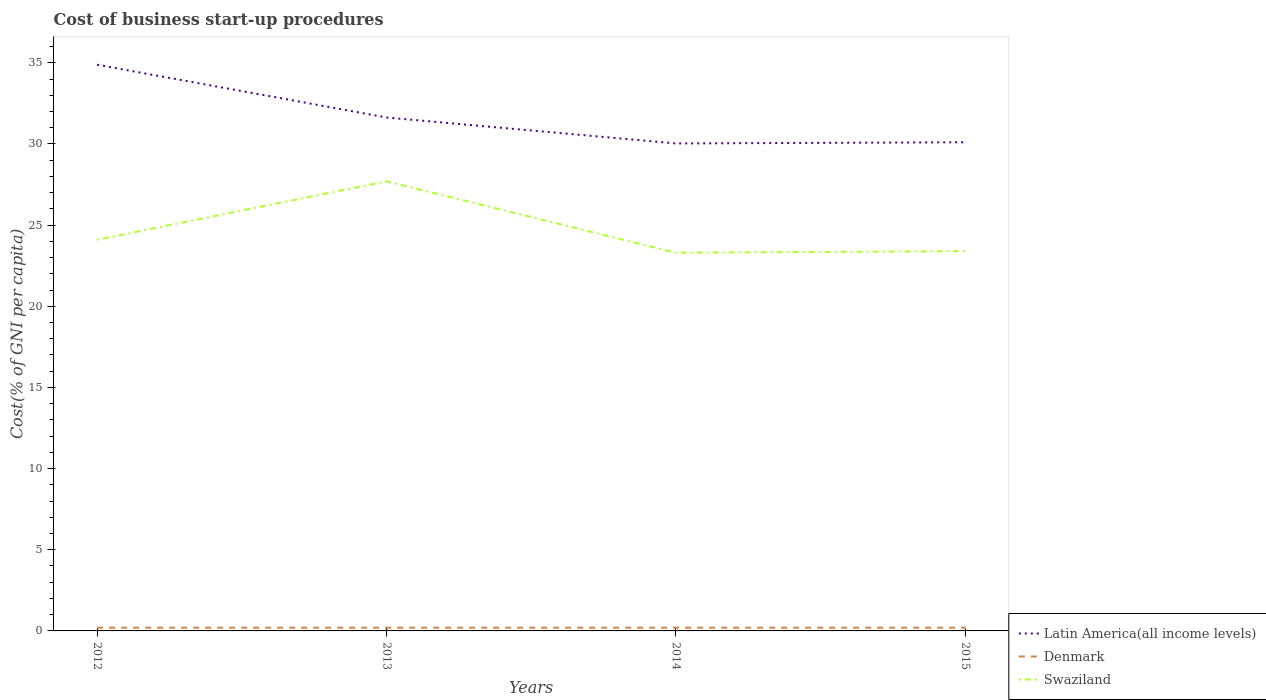Does the line corresponding to Swaziland intersect with the line corresponding to Latin America(all income levels)?
Give a very brief answer. No. Is the number of lines equal to the number of legend labels?
Keep it short and to the point. Yes. Across all years, what is the maximum cost of business start-up procedures in Swaziland?
Your answer should be compact. 23.3. What is the total cost of business start-up procedures in Latin America(all income levels) in the graph?
Keep it short and to the point. -0.07. What is the difference between the highest and the second highest cost of business start-up procedures in Latin America(all income levels)?
Keep it short and to the point. 4.85. What is the difference between the highest and the lowest cost of business start-up procedures in Latin America(all income levels)?
Provide a succinct answer. 1. Is the cost of business start-up procedures in Denmark strictly greater than the cost of business start-up procedures in Latin America(all income levels) over the years?
Your answer should be compact. Yes. How many lines are there?
Your answer should be very brief. 3. How many years are there in the graph?
Keep it short and to the point. 4. What is the difference between two consecutive major ticks on the Y-axis?
Provide a short and direct response. 5. Are the values on the major ticks of Y-axis written in scientific E-notation?
Offer a very short reply. No. How are the legend labels stacked?
Provide a short and direct response. Vertical. What is the title of the graph?
Your answer should be compact. Cost of business start-up procedures. Does "French Polynesia" appear as one of the legend labels in the graph?
Your response must be concise. No. What is the label or title of the X-axis?
Keep it short and to the point. Years. What is the label or title of the Y-axis?
Your response must be concise. Cost(% of GNI per capita). What is the Cost(% of GNI per capita) in Latin America(all income levels) in 2012?
Ensure brevity in your answer.  34.88. What is the Cost(% of GNI per capita) of Denmark in 2012?
Provide a succinct answer. 0.2. What is the Cost(% of GNI per capita) of Swaziland in 2012?
Offer a terse response. 24.1. What is the Cost(% of GNI per capita) in Latin America(all income levels) in 2013?
Give a very brief answer. 31.63. What is the Cost(% of GNI per capita) of Swaziland in 2013?
Keep it short and to the point. 27.7. What is the Cost(% of GNI per capita) of Latin America(all income levels) in 2014?
Make the answer very short. 30.03. What is the Cost(% of GNI per capita) in Swaziland in 2014?
Your answer should be compact. 23.3. What is the Cost(% of GNI per capita) of Latin America(all income levels) in 2015?
Make the answer very short. 30.11. What is the Cost(% of GNI per capita) in Denmark in 2015?
Give a very brief answer. 0.2. What is the Cost(% of GNI per capita) in Swaziland in 2015?
Provide a short and direct response. 23.4. Across all years, what is the maximum Cost(% of GNI per capita) in Latin America(all income levels)?
Keep it short and to the point. 34.88. Across all years, what is the maximum Cost(% of GNI per capita) of Swaziland?
Make the answer very short. 27.7. Across all years, what is the minimum Cost(% of GNI per capita) of Latin America(all income levels)?
Make the answer very short. 30.03. Across all years, what is the minimum Cost(% of GNI per capita) of Swaziland?
Keep it short and to the point. 23.3. What is the total Cost(% of GNI per capita) in Latin America(all income levels) in the graph?
Offer a very short reply. 126.66. What is the total Cost(% of GNI per capita) of Denmark in the graph?
Offer a terse response. 0.8. What is the total Cost(% of GNI per capita) of Swaziland in the graph?
Offer a terse response. 98.5. What is the difference between the Cost(% of GNI per capita) of Latin America(all income levels) in 2012 and that in 2013?
Your answer should be very brief. 3.25. What is the difference between the Cost(% of GNI per capita) of Denmark in 2012 and that in 2013?
Your answer should be compact. 0. What is the difference between the Cost(% of GNI per capita) of Latin America(all income levels) in 2012 and that in 2014?
Keep it short and to the point. 4.85. What is the difference between the Cost(% of GNI per capita) of Latin America(all income levels) in 2012 and that in 2015?
Keep it short and to the point. 4.78. What is the difference between the Cost(% of GNI per capita) of Denmark in 2012 and that in 2015?
Your response must be concise. 0. What is the difference between the Cost(% of GNI per capita) in Swaziland in 2012 and that in 2015?
Ensure brevity in your answer.  0.7. What is the difference between the Cost(% of GNI per capita) of Swaziland in 2013 and that in 2014?
Ensure brevity in your answer.  4.4. What is the difference between the Cost(% of GNI per capita) in Latin America(all income levels) in 2013 and that in 2015?
Provide a short and direct response. 1.53. What is the difference between the Cost(% of GNI per capita) in Denmark in 2013 and that in 2015?
Ensure brevity in your answer.  0. What is the difference between the Cost(% of GNI per capita) of Swaziland in 2013 and that in 2015?
Offer a very short reply. 4.3. What is the difference between the Cost(% of GNI per capita) of Latin America(all income levels) in 2014 and that in 2015?
Your answer should be compact. -0.07. What is the difference between the Cost(% of GNI per capita) of Denmark in 2014 and that in 2015?
Offer a very short reply. 0. What is the difference between the Cost(% of GNI per capita) of Swaziland in 2014 and that in 2015?
Offer a very short reply. -0.1. What is the difference between the Cost(% of GNI per capita) in Latin America(all income levels) in 2012 and the Cost(% of GNI per capita) in Denmark in 2013?
Your response must be concise. 34.68. What is the difference between the Cost(% of GNI per capita) in Latin America(all income levels) in 2012 and the Cost(% of GNI per capita) in Swaziland in 2013?
Provide a succinct answer. 7.18. What is the difference between the Cost(% of GNI per capita) in Denmark in 2012 and the Cost(% of GNI per capita) in Swaziland in 2013?
Your answer should be very brief. -27.5. What is the difference between the Cost(% of GNI per capita) in Latin America(all income levels) in 2012 and the Cost(% of GNI per capita) in Denmark in 2014?
Your answer should be compact. 34.68. What is the difference between the Cost(% of GNI per capita) in Latin America(all income levels) in 2012 and the Cost(% of GNI per capita) in Swaziland in 2014?
Offer a terse response. 11.58. What is the difference between the Cost(% of GNI per capita) of Denmark in 2012 and the Cost(% of GNI per capita) of Swaziland in 2014?
Your answer should be very brief. -23.1. What is the difference between the Cost(% of GNI per capita) in Latin America(all income levels) in 2012 and the Cost(% of GNI per capita) in Denmark in 2015?
Provide a short and direct response. 34.68. What is the difference between the Cost(% of GNI per capita) in Latin America(all income levels) in 2012 and the Cost(% of GNI per capita) in Swaziland in 2015?
Your answer should be compact. 11.48. What is the difference between the Cost(% of GNI per capita) of Denmark in 2012 and the Cost(% of GNI per capita) of Swaziland in 2015?
Offer a very short reply. -23.2. What is the difference between the Cost(% of GNI per capita) of Latin America(all income levels) in 2013 and the Cost(% of GNI per capita) of Denmark in 2014?
Your response must be concise. 31.43. What is the difference between the Cost(% of GNI per capita) in Latin America(all income levels) in 2013 and the Cost(% of GNI per capita) in Swaziland in 2014?
Provide a succinct answer. 8.33. What is the difference between the Cost(% of GNI per capita) of Denmark in 2013 and the Cost(% of GNI per capita) of Swaziland in 2014?
Offer a very short reply. -23.1. What is the difference between the Cost(% of GNI per capita) in Latin America(all income levels) in 2013 and the Cost(% of GNI per capita) in Denmark in 2015?
Your response must be concise. 31.43. What is the difference between the Cost(% of GNI per capita) of Latin America(all income levels) in 2013 and the Cost(% of GNI per capita) of Swaziland in 2015?
Your answer should be very brief. 8.23. What is the difference between the Cost(% of GNI per capita) of Denmark in 2013 and the Cost(% of GNI per capita) of Swaziland in 2015?
Offer a very short reply. -23.2. What is the difference between the Cost(% of GNI per capita) of Latin America(all income levels) in 2014 and the Cost(% of GNI per capita) of Denmark in 2015?
Offer a very short reply. 29.83. What is the difference between the Cost(% of GNI per capita) in Latin America(all income levels) in 2014 and the Cost(% of GNI per capita) in Swaziland in 2015?
Ensure brevity in your answer.  6.63. What is the difference between the Cost(% of GNI per capita) in Denmark in 2014 and the Cost(% of GNI per capita) in Swaziland in 2015?
Your answer should be very brief. -23.2. What is the average Cost(% of GNI per capita) of Latin America(all income levels) per year?
Give a very brief answer. 31.66. What is the average Cost(% of GNI per capita) of Swaziland per year?
Provide a short and direct response. 24.62. In the year 2012, what is the difference between the Cost(% of GNI per capita) in Latin America(all income levels) and Cost(% of GNI per capita) in Denmark?
Your answer should be compact. 34.68. In the year 2012, what is the difference between the Cost(% of GNI per capita) in Latin America(all income levels) and Cost(% of GNI per capita) in Swaziland?
Make the answer very short. 10.78. In the year 2012, what is the difference between the Cost(% of GNI per capita) in Denmark and Cost(% of GNI per capita) in Swaziland?
Ensure brevity in your answer.  -23.9. In the year 2013, what is the difference between the Cost(% of GNI per capita) in Latin America(all income levels) and Cost(% of GNI per capita) in Denmark?
Your answer should be compact. 31.43. In the year 2013, what is the difference between the Cost(% of GNI per capita) of Latin America(all income levels) and Cost(% of GNI per capita) of Swaziland?
Give a very brief answer. 3.93. In the year 2013, what is the difference between the Cost(% of GNI per capita) of Denmark and Cost(% of GNI per capita) of Swaziland?
Your response must be concise. -27.5. In the year 2014, what is the difference between the Cost(% of GNI per capita) of Latin America(all income levels) and Cost(% of GNI per capita) of Denmark?
Your answer should be very brief. 29.83. In the year 2014, what is the difference between the Cost(% of GNI per capita) of Latin America(all income levels) and Cost(% of GNI per capita) of Swaziland?
Provide a short and direct response. 6.73. In the year 2014, what is the difference between the Cost(% of GNI per capita) in Denmark and Cost(% of GNI per capita) in Swaziland?
Keep it short and to the point. -23.1. In the year 2015, what is the difference between the Cost(% of GNI per capita) of Latin America(all income levels) and Cost(% of GNI per capita) of Denmark?
Your answer should be compact. 29.91. In the year 2015, what is the difference between the Cost(% of GNI per capita) in Latin America(all income levels) and Cost(% of GNI per capita) in Swaziland?
Ensure brevity in your answer.  6.71. In the year 2015, what is the difference between the Cost(% of GNI per capita) of Denmark and Cost(% of GNI per capita) of Swaziland?
Keep it short and to the point. -23.2. What is the ratio of the Cost(% of GNI per capita) of Latin America(all income levels) in 2012 to that in 2013?
Your answer should be very brief. 1.1. What is the ratio of the Cost(% of GNI per capita) in Swaziland in 2012 to that in 2013?
Make the answer very short. 0.87. What is the ratio of the Cost(% of GNI per capita) of Latin America(all income levels) in 2012 to that in 2014?
Keep it short and to the point. 1.16. What is the ratio of the Cost(% of GNI per capita) of Swaziland in 2012 to that in 2014?
Your answer should be compact. 1.03. What is the ratio of the Cost(% of GNI per capita) of Latin America(all income levels) in 2012 to that in 2015?
Make the answer very short. 1.16. What is the ratio of the Cost(% of GNI per capita) of Swaziland in 2012 to that in 2015?
Provide a short and direct response. 1.03. What is the ratio of the Cost(% of GNI per capita) in Latin America(all income levels) in 2013 to that in 2014?
Give a very brief answer. 1.05. What is the ratio of the Cost(% of GNI per capita) of Denmark in 2013 to that in 2014?
Provide a short and direct response. 1. What is the ratio of the Cost(% of GNI per capita) in Swaziland in 2013 to that in 2014?
Provide a succinct answer. 1.19. What is the ratio of the Cost(% of GNI per capita) of Latin America(all income levels) in 2013 to that in 2015?
Your response must be concise. 1.05. What is the ratio of the Cost(% of GNI per capita) of Denmark in 2013 to that in 2015?
Give a very brief answer. 1. What is the ratio of the Cost(% of GNI per capita) in Swaziland in 2013 to that in 2015?
Offer a very short reply. 1.18. What is the ratio of the Cost(% of GNI per capita) in Latin America(all income levels) in 2014 to that in 2015?
Your answer should be compact. 1. What is the ratio of the Cost(% of GNI per capita) in Denmark in 2014 to that in 2015?
Offer a very short reply. 1. What is the ratio of the Cost(% of GNI per capita) in Swaziland in 2014 to that in 2015?
Provide a succinct answer. 1. What is the difference between the highest and the second highest Cost(% of GNI per capita) in Latin America(all income levels)?
Provide a short and direct response. 3.25. What is the difference between the highest and the second highest Cost(% of GNI per capita) in Denmark?
Ensure brevity in your answer.  0. What is the difference between the highest and the lowest Cost(% of GNI per capita) of Latin America(all income levels)?
Your response must be concise. 4.85. What is the difference between the highest and the lowest Cost(% of GNI per capita) in Denmark?
Your answer should be very brief. 0. What is the difference between the highest and the lowest Cost(% of GNI per capita) of Swaziland?
Ensure brevity in your answer.  4.4. 